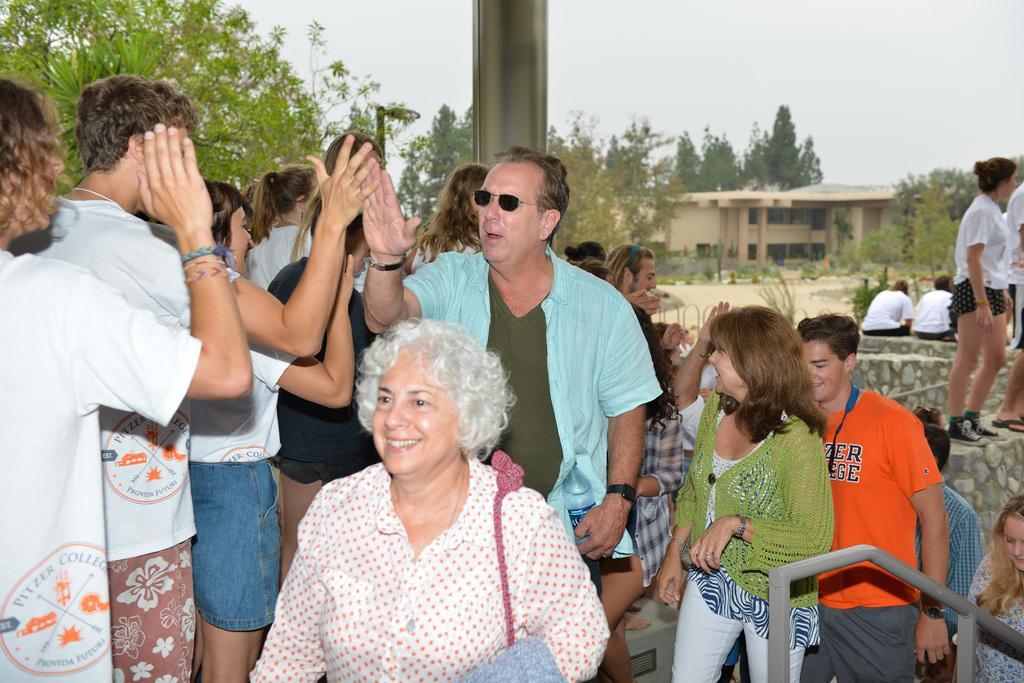In one or two sentences, can you explain what this image depicts? In this picture I can see a group of people are standing. On the right side I can see buildings, trees and the sky. I can also see a metal object. The woman in the front is smiling and carrying an object. In the background I can see a pole. 